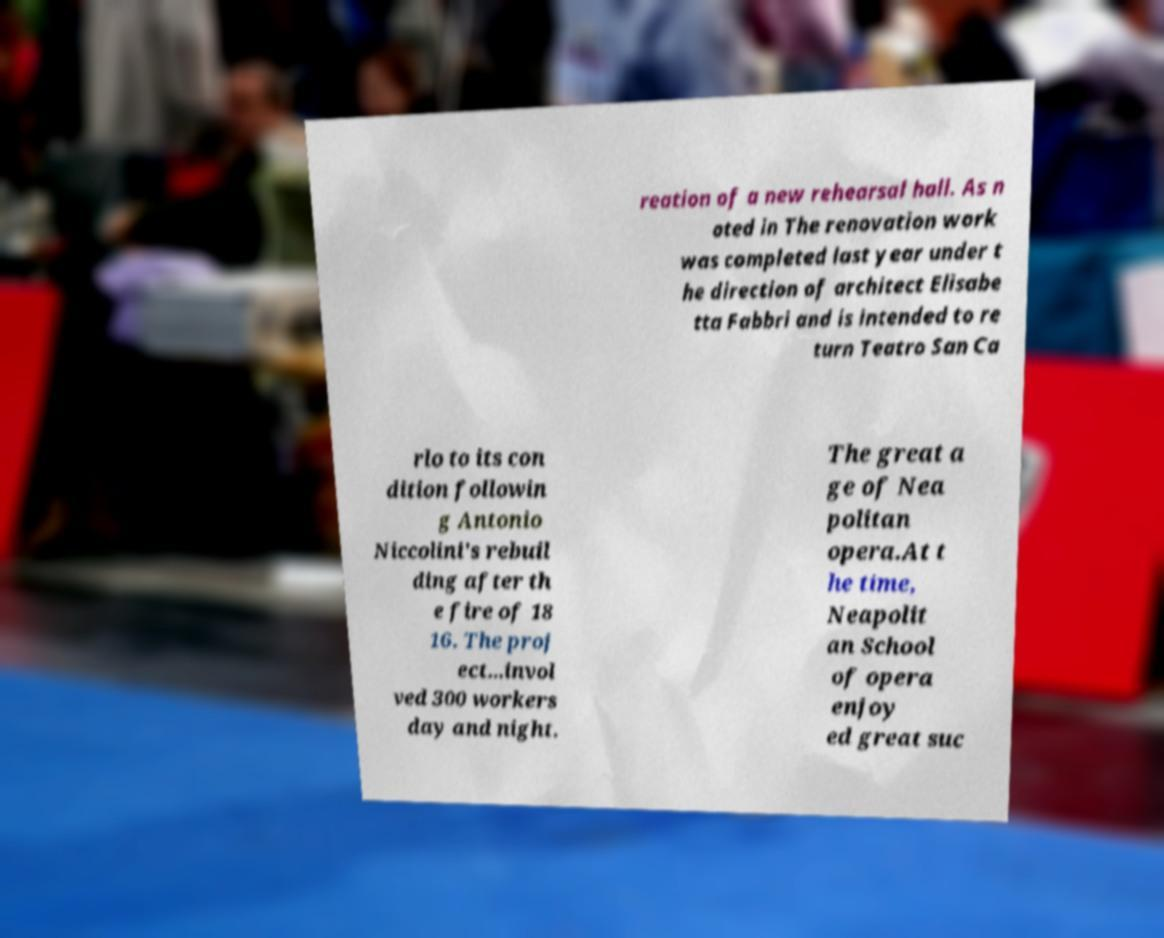What messages or text are displayed in this image? I need them in a readable, typed format. reation of a new rehearsal hall. As n oted in The renovation work was completed last year under t he direction of architect Elisabe tta Fabbri and is intended to re turn Teatro San Ca rlo to its con dition followin g Antonio Niccolini's rebuil ding after th e fire of 18 16. The proj ect...invol ved 300 workers day and night. The great a ge of Nea politan opera.At t he time, Neapolit an School of opera enjoy ed great suc 